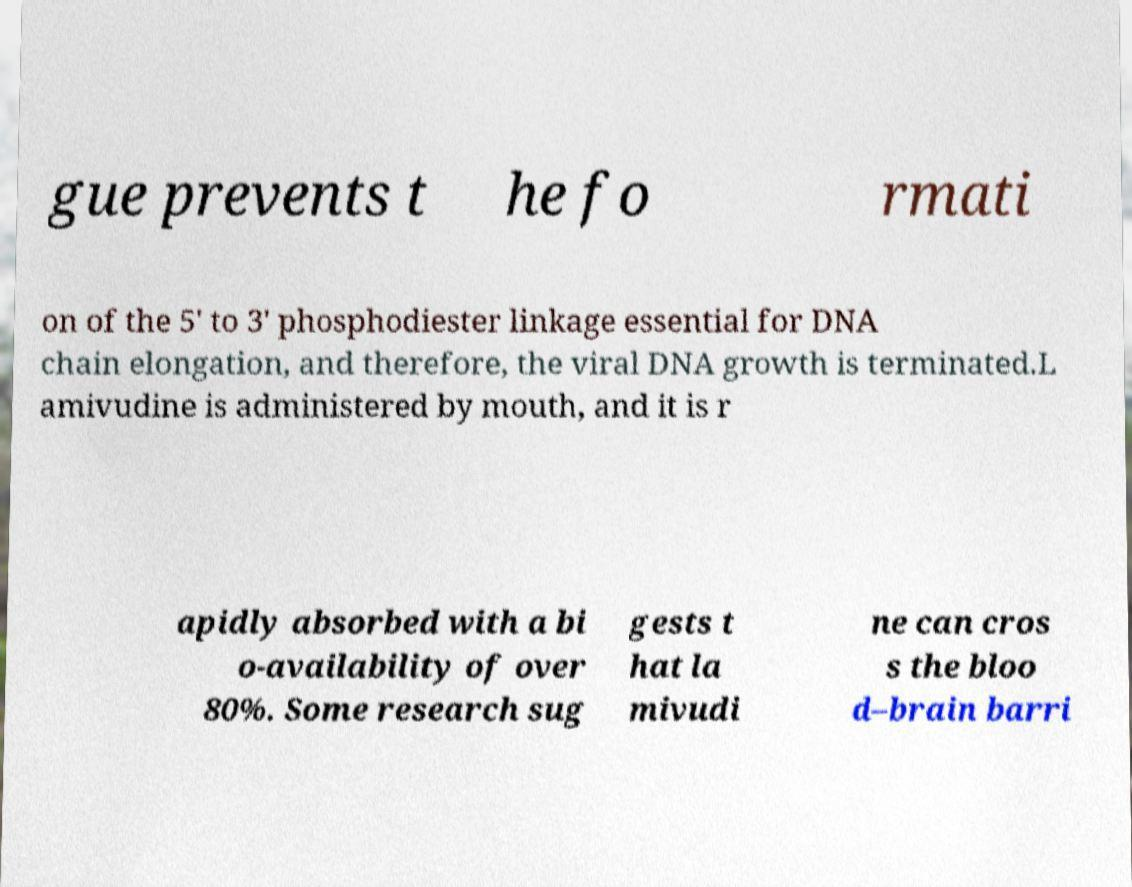I need the written content from this picture converted into text. Can you do that? gue prevents t he fo rmati on of the 5' to 3' phosphodiester linkage essential for DNA chain elongation, and therefore, the viral DNA growth is terminated.L amivudine is administered by mouth, and it is r apidly absorbed with a bi o-availability of over 80%. Some research sug gests t hat la mivudi ne can cros s the bloo d–brain barri 